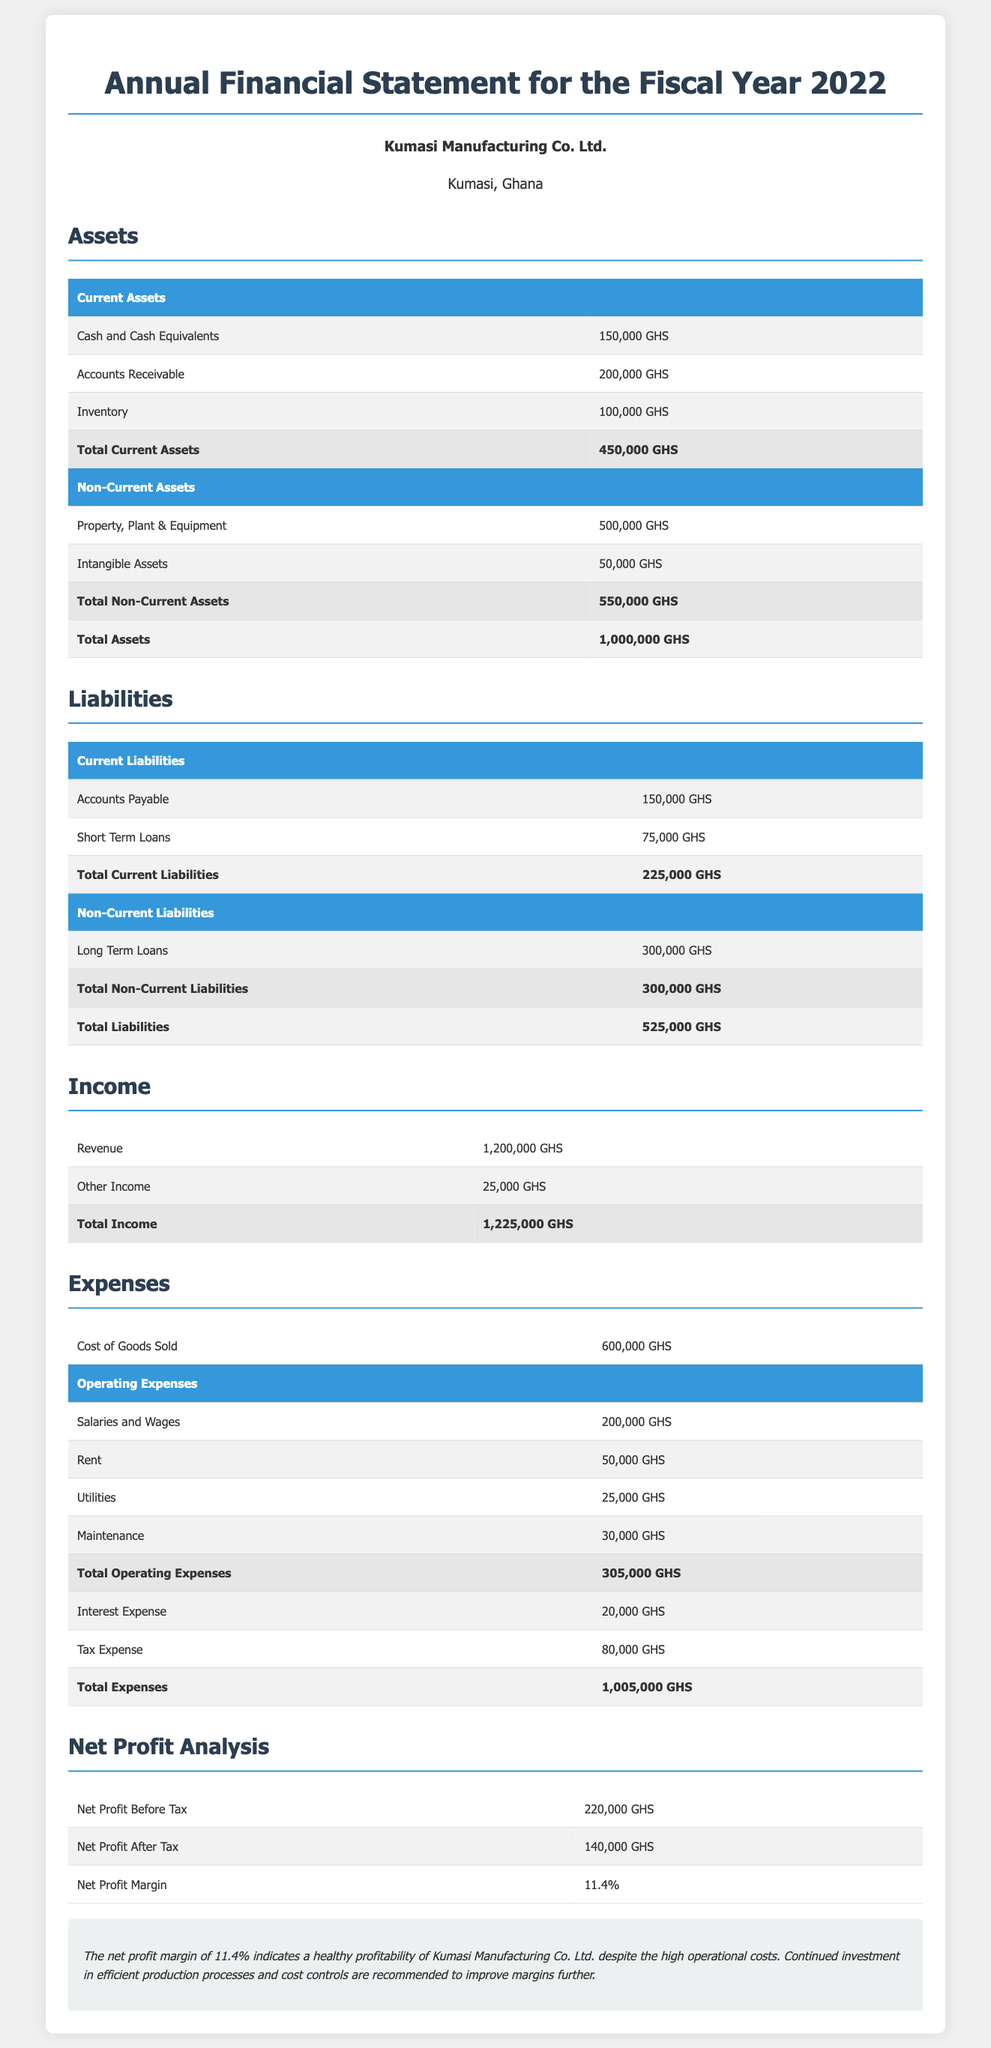what is the total current assets? The total current assets are calculated by summing all current asset items listed in the document, which are Cash and Cash Equivalents, Accounts Receivable, and Inventory.
Answer: 450,000 GHS what is the total liabilities? The total liabilities are found by adding the total current liabilities and total non-current liabilities in the document.
Answer: 525,000 GHS what is the total income? The total income is the sum of Revenue and Other Income as presented in the statement.
Answer: 1,225,000 GHS what is the net profit after tax? The net profit after tax is explicitly stated in the document as the profit remaining after tax expenses.
Answer: 140,000 GHS what is the net profit margin? The net profit margin indicates the percentage of net profit in relation to total revenue and is listed in the report.
Answer: 11.4% what are the total operating expenses? The total operating expenses are compiled from various operating costs provided in the expenses section.
Answer: 305,000 GHS what is the cost of goods sold? The cost of goods sold is a part of the expenses in the document, indicating the direct costs attributable to the production of the goods sold.
Answer: 600,000 GHS what financial year does this statement cover? The document clearly states the fiscal year it pertains to, specifically indicating the time frame of the financial information presented.
Answer: 2022 who is the company associated with this financial statement? The document provides the name of the company at the top of the report, which identifies the entity responsible for the statement.
Answer: Kumasi Manufacturing Co. Ltd 